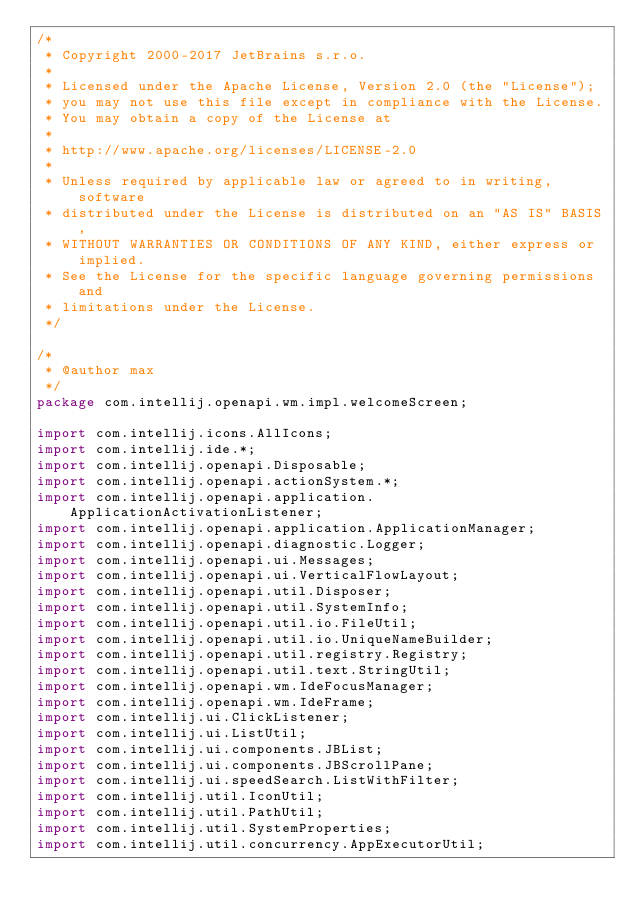<code> <loc_0><loc_0><loc_500><loc_500><_Java_>/*
 * Copyright 2000-2017 JetBrains s.r.o.
 *
 * Licensed under the Apache License, Version 2.0 (the "License");
 * you may not use this file except in compliance with the License.
 * You may obtain a copy of the License at
 *
 * http://www.apache.org/licenses/LICENSE-2.0
 *
 * Unless required by applicable law or agreed to in writing, software
 * distributed under the License is distributed on an "AS IS" BASIS,
 * WITHOUT WARRANTIES OR CONDITIONS OF ANY KIND, either express or implied.
 * See the License for the specific language governing permissions and
 * limitations under the License.
 */

/*
 * @author max
 */
package com.intellij.openapi.wm.impl.welcomeScreen;

import com.intellij.icons.AllIcons;
import com.intellij.ide.*;
import com.intellij.openapi.Disposable;
import com.intellij.openapi.actionSystem.*;
import com.intellij.openapi.application.ApplicationActivationListener;
import com.intellij.openapi.application.ApplicationManager;
import com.intellij.openapi.diagnostic.Logger;
import com.intellij.openapi.ui.Messages;
import com.intellij.openapi.ui.VerticalFlowLayout;
import com.intellij.openapi.util.Disposer;
import com.intellij.openapi.util.SystemInfo;
import com.intellij.openapi.util.io.FileUtil;
import com.intellij.openapi.util.io.UniqueNameBuilder;
import com.intellij.openapi.util.registry.Registry;
import com.intellij.openapi.util.text.StringUtil;
import com.intellij.openapi.wm.IdeFocusManager;
import com.intellij.openapi.wm.IdeFrame;
import com.intellij.ui.ClickListener;
import com.intellij.ui.ListUtil;
import com.intellij.ui.components.JBList;
import com.intellij.ui.components.JBScrollPane;
import com.intellij.ui.speedSearch.ListWithFilter;
import com.intellij.util.IconUtil;
import com.intellij.util.PathUtil;
import com.intellij.util.SystemProperties;
import com.intellij.util.concurrency.AppExecutorUtil;</code> 